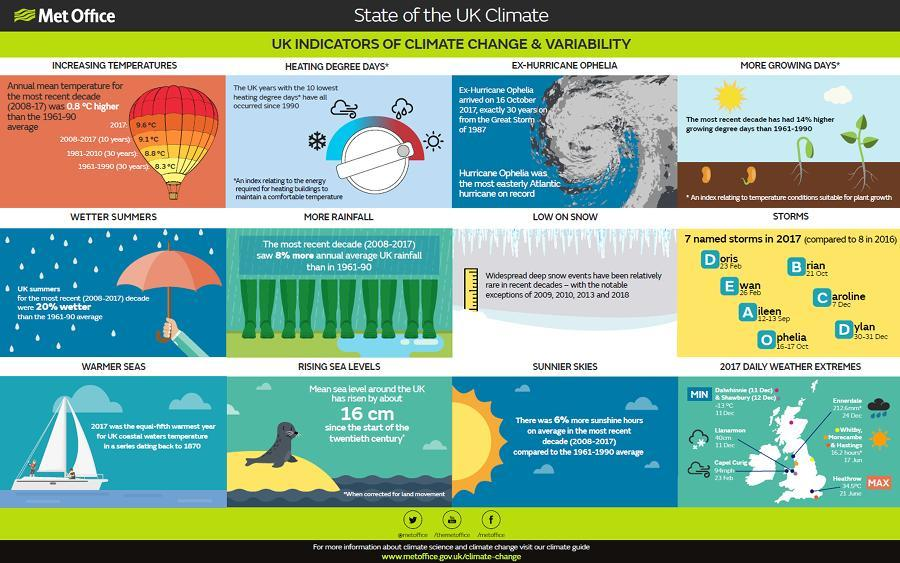When did the Ex-Hurricane Ophelia occurred in UK?
Answer the question with a short phrase. 16 October 2017 When was the storm named "Brian" occurred in UK? 21 Oct, 2017 When did the storm called Dylan occurred in UK? 30-31 Dec 